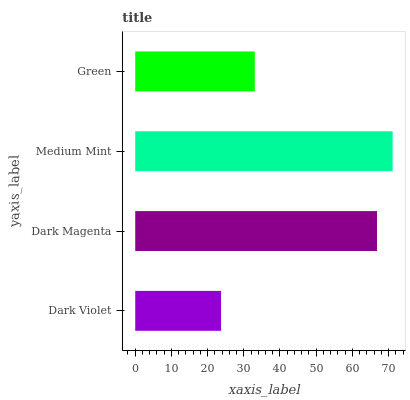Is Dark Violet the minimum?
Answer yes or no. Yes. Is Medium Mint the maximum?
Answer yes or no. Yes. Is Dark Magenta the minimum?
Answer yes or no. No. Is Dark Magenta the maximum?
Answer yes or no. No. Is Dark Magenta greater than Dark Violet?
Answer yes or no. Yes. Is Dark Violet less than Dark Magenta?
Answer yes or no. Yes. Is Dark Violet greater than Dark Magenta?
Answer yes or no. No. Is Dark Magenta less than Dark Violet?
Answer yes or no. No. Is Dark Magenta the high median?
Answer yes or no. Yes. Is Green the low median?
Answer yes or no. Yes. Is Dark Violet the high median?
Answer yes or no. No. Is Medium Mint the low median?
Answer yes or no. No. 